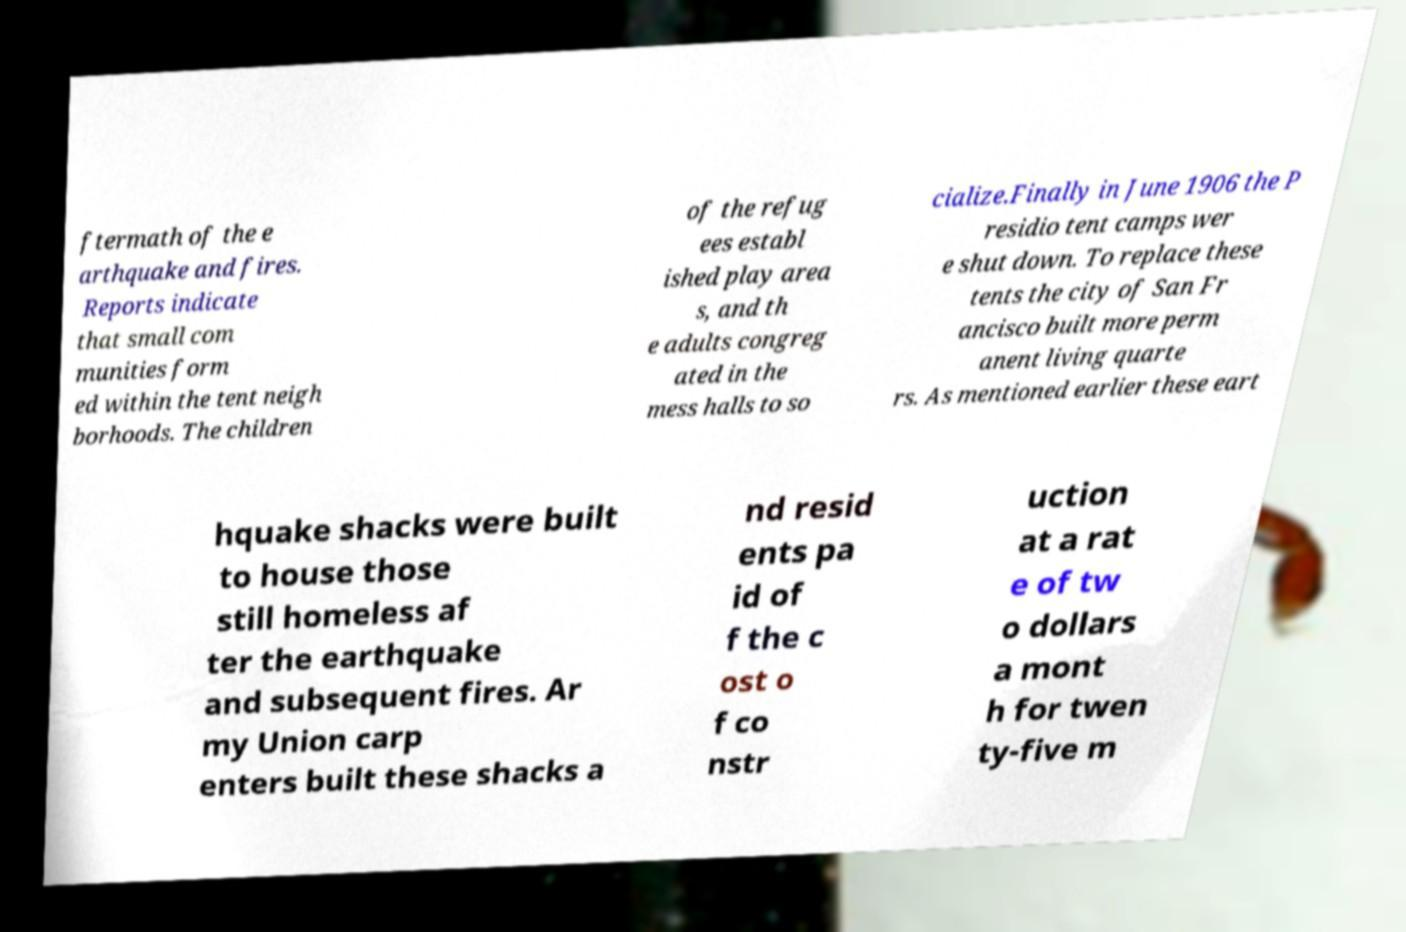For documentation purposes, I need the text within this image transcribed. Could you provide that? ftermath of the e arthquake and fires. Reports indicate that small com munities form ed within the tent neigh borhoods. The children of the refug ees establ ished play area s, and th e adults congreg ated in the mess halls to so cialize.Finally in June 1906 the P residio tent camps wer e shut down. To replace these tents the city of San Fr ancisco built more perm anent living quarte rs. As mentioned earlier these eart hquake shacks were built to house those still homeless af ter the earthquake and subsequent fires. Ar my Union carp enters built these shacks a nd resid ents pa id of f the c ost o f co nstr uction at a rat e of tw o dollars a mont h for twen ty-five m 